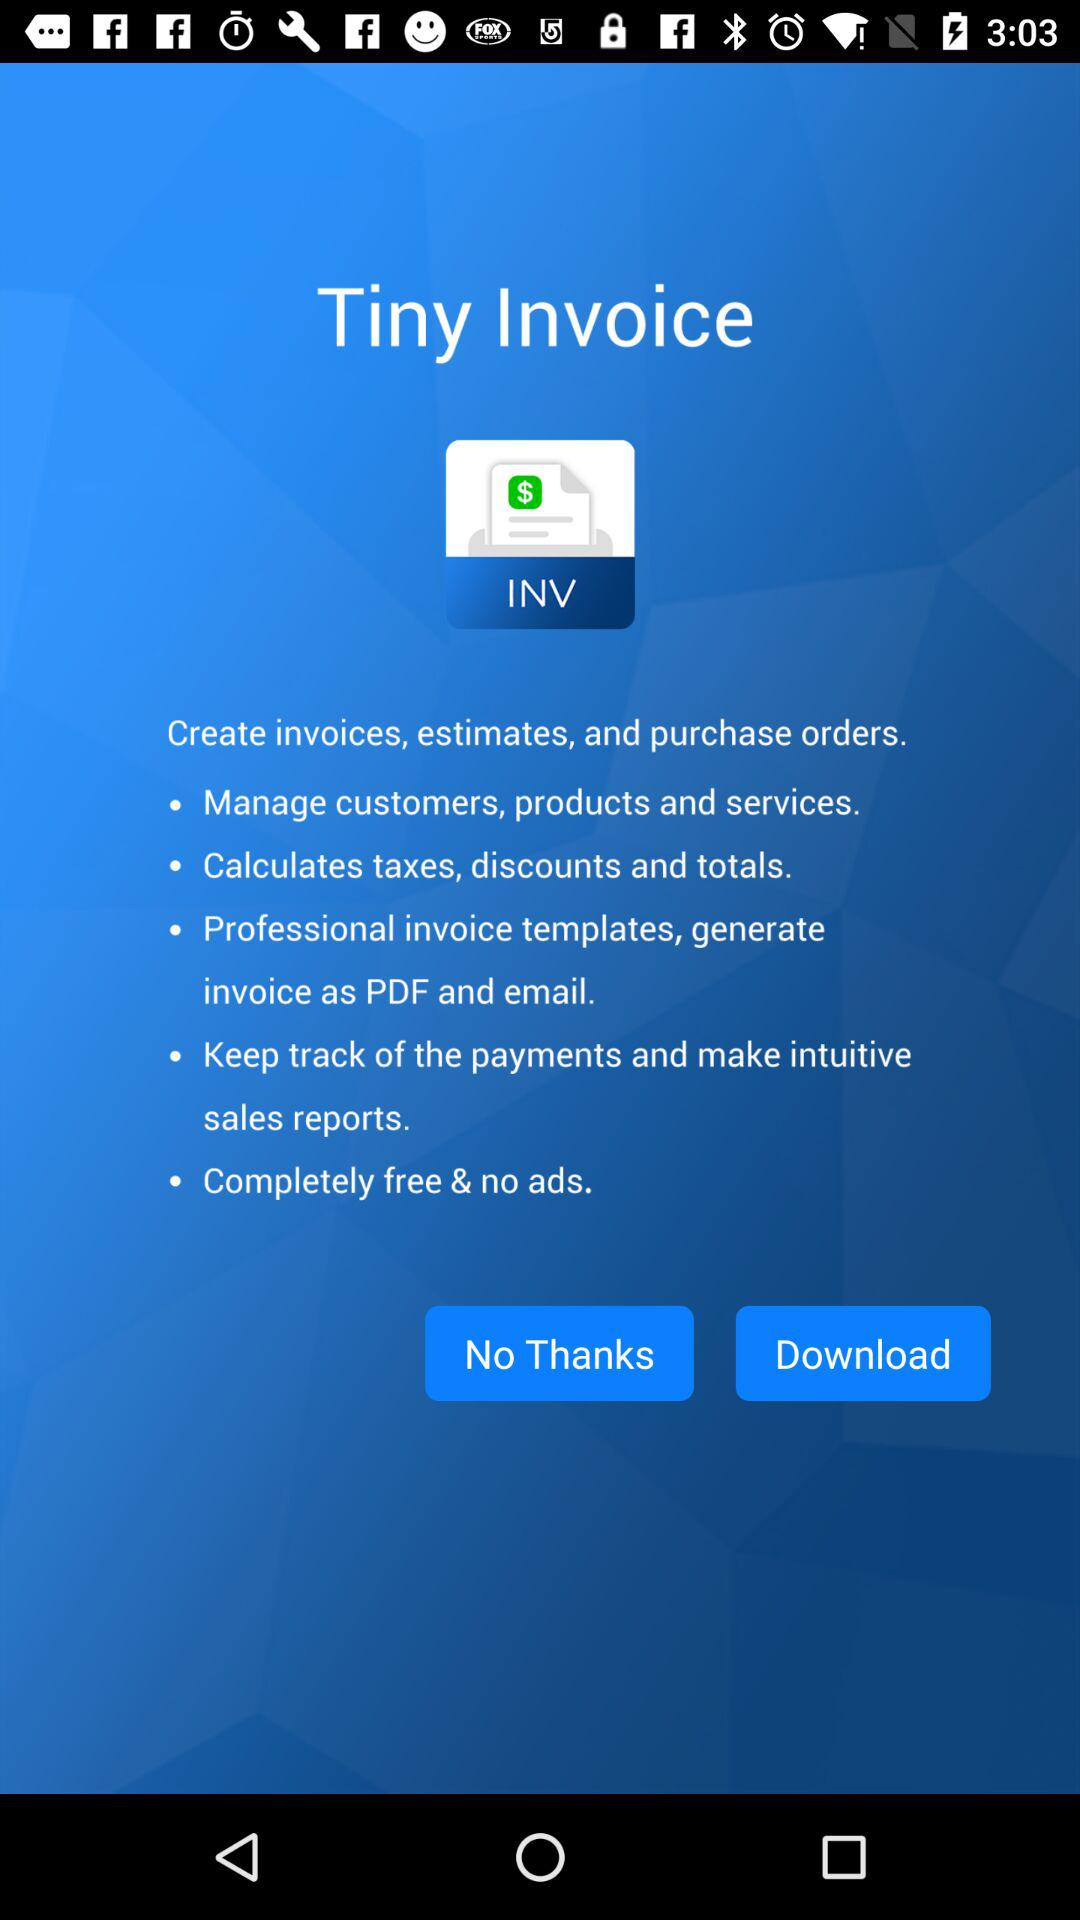What is the name of the application? The name of the application is "Tiny Invoice". 